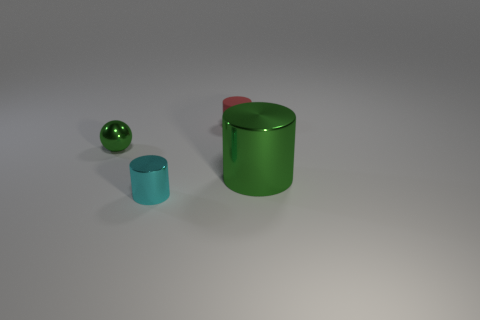Subtract all tiny cylinders. How many cylinders are left? 1 Add 2 brown metal blocks. How many objects exist? 6 Subtract all spheres. How many objects are left? 3 Subtract all red cylinders. Subtract all green cubes. How many cylinders are left? 2 Subtract all blue blocks. How many green cylinders are left? 1 Subtract all red matte cylinders. Subtract all small green matte things. How many objects are left? 3 Add 4 large green objects. How many large green objects are left? 5 Add 2 small shiny balls. How many small shiny balls exist? 3 Subtract 0 purple cubes. How many objects are left? 4 